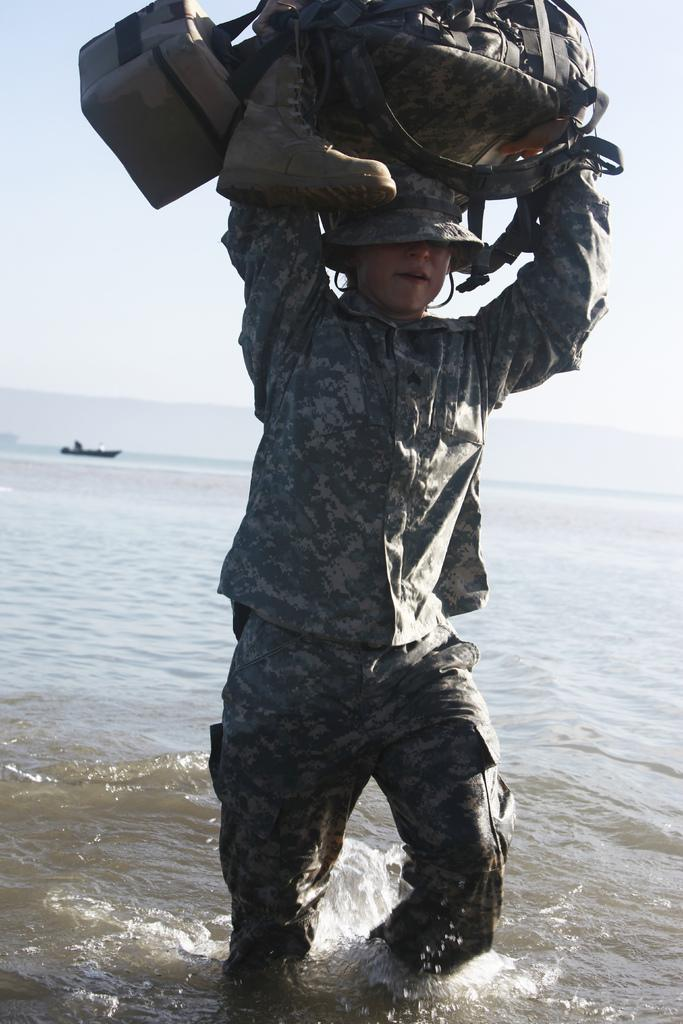What type of person is in the image? There is an army person in the image. What is the army person carrying on their head? The army person is carrying bags and shoes on their head. What type of clothing is the army person wearing? The army person is wearing an army uniform. What can be seen in the background of the image? There is a sea visible in the background of the image. What is present on the surface of the water in the image? There is a boat on the surface of the water. What type of quince is being used as a prop in the image? There is no quince present in the image. How many toothbrushes can be seen in the image? There are no toothbrushes present in the image. 